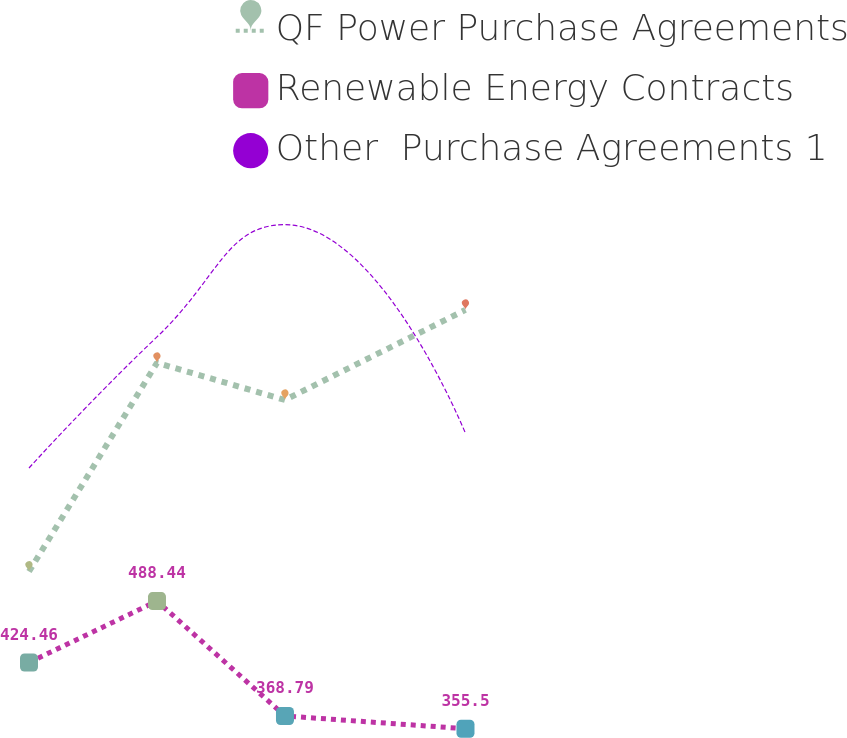Convert chart. <chart><loc_0><loc_0><loc_500><loc_500><line_chart><ecel><fcel>QF Power Purchase Agreements<fcel>Renewable Energy Contracts<fcel>Other  Purchase Agreements 1<nl><fcel>1657.92<fcel>519.26<fcel>424.46<fcel>627.1<nl><fcel>1707.78<fcel>736.61<fcel>488.44<fcel>763.63<nl><fcel>1757.64<fcel>697.97<fcel>368.79<fcel>880.57<nl><fcel>1827.96<fcel>791.8<fcel>355.5<fcel>663.14<nl><fcel>2156.56<fcel>642.66<fcel>387.64<fcel>520.12<nl></chart> 